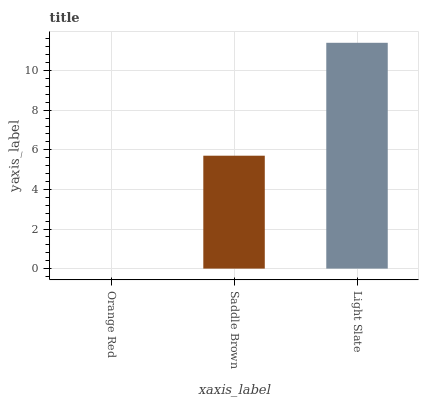Is Orange Red the minimum?
Answer yes or no. Yes. Is Light Slate the maximum?
Answer yes or no. Yes. Is Saddle Brown the minimum?
Answer yes or no. No. Is Saddle Brown the maximum?
Answer yes or no. No. Is Saddle Brown greater than Orange Red?
Answer yes or no. Yes. Is Orange Red less than Saddle Brown?
Answer yes or no. Yes. Is Orange Red greater than Saddle Brown?
Answer yes or no. No. Is Saddle Brown less than Orange Red?
Answer yes or no. No. Is Saddle Brown the high median?
Answer yes or no. Yes. Is Saddle Brown the low median?
Answer yes or no. Yes. Is Light Slate the high median?
Answer yes or no. No. Is Light Slate the low median?
Answer yes or no. No. 